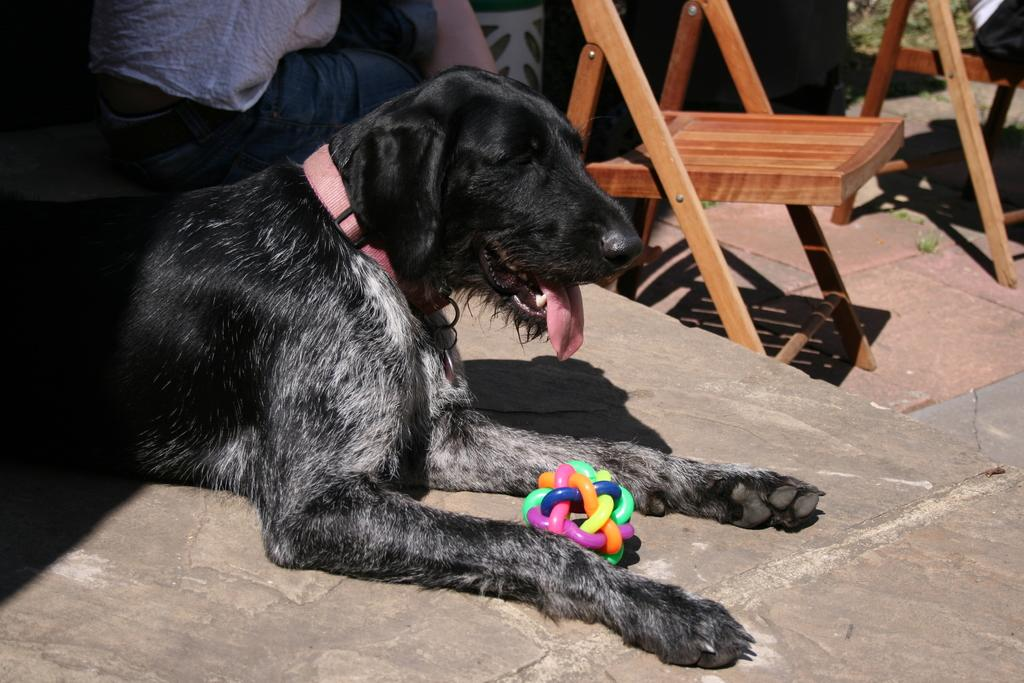What type of animal is in the image? There is a dog in the image. What is unique about the dog's appearance? The dog's neck has a belt. Who is present on the left side of the image? There is a person on the left side of the image. What is the person doing in the image? The person is sitting. What can be seen in the background of the image? There is a chair visible in the background of the image. What type of garden can be seen in the image? There is no garden present in the image. How does the person sneeze in the image? There is no indication of the person sneezing in the image. 